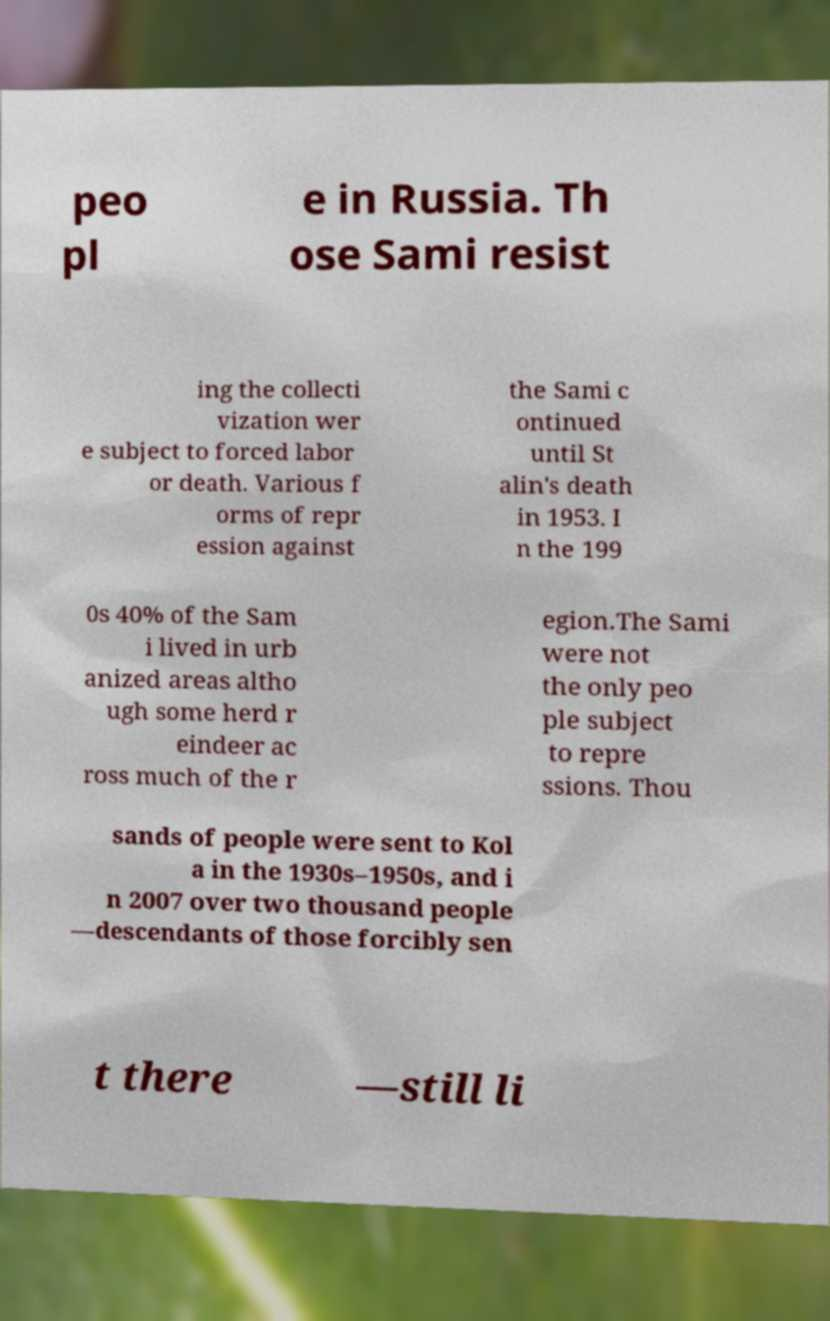Could you extract and type out the text from this image? peo pl e in Russia. Th ose Sami resist ing the collecti vization wer e subject to forced labor or death. Various f orms of repr ession against the Sami c ontinued until St alin's death in 1953. I n the 199 0s 40% of the Sam i lived in urb anized areas altho ugh some herd r eindeer ac ross much of the r egion.The Sami were not the only peo ple subject to repre ssions. Thou sands of people were sent to Kol a in the 1930s–1950s, and i n 2007 over two thousand people —descendants of those forcibly sen t there —still li 